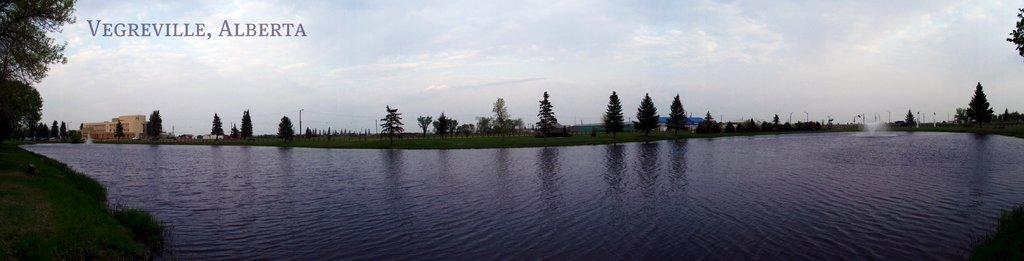How would you summarize this image in a sentence or two? In this image I can see water in the front and around it I can see grass ground and number of trees. On the right side of the image I can see a water fountain. In the background I can see number of poles, few wires, clouds and the sky. I can also see two buildings on the both sides of the image and on the top left side of the image I can see a watermark. 